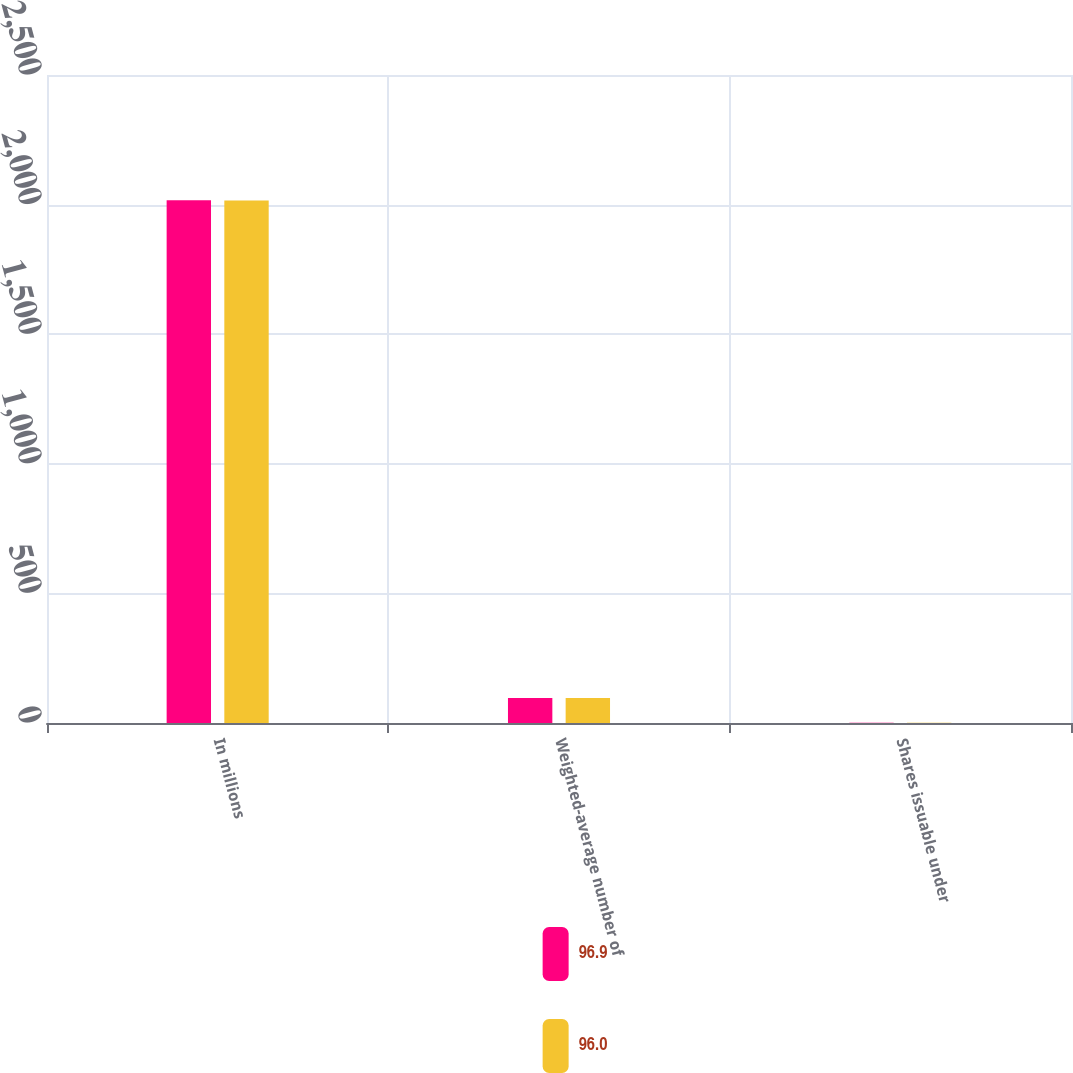Convert chart. <chart><loc_0><loc_0><loc_500><loc_500><stacked_bar_chart><ecel><fcel>In millions<fcel>Weighted-average number of<fcel>Shares issuable under<nl><fcel>96.9<fcel>2017<fcel>96<fcel>0.9<nl><fcel>96<fcel>2016<fcel>96.9<fcel>1.1<nl></chart> 